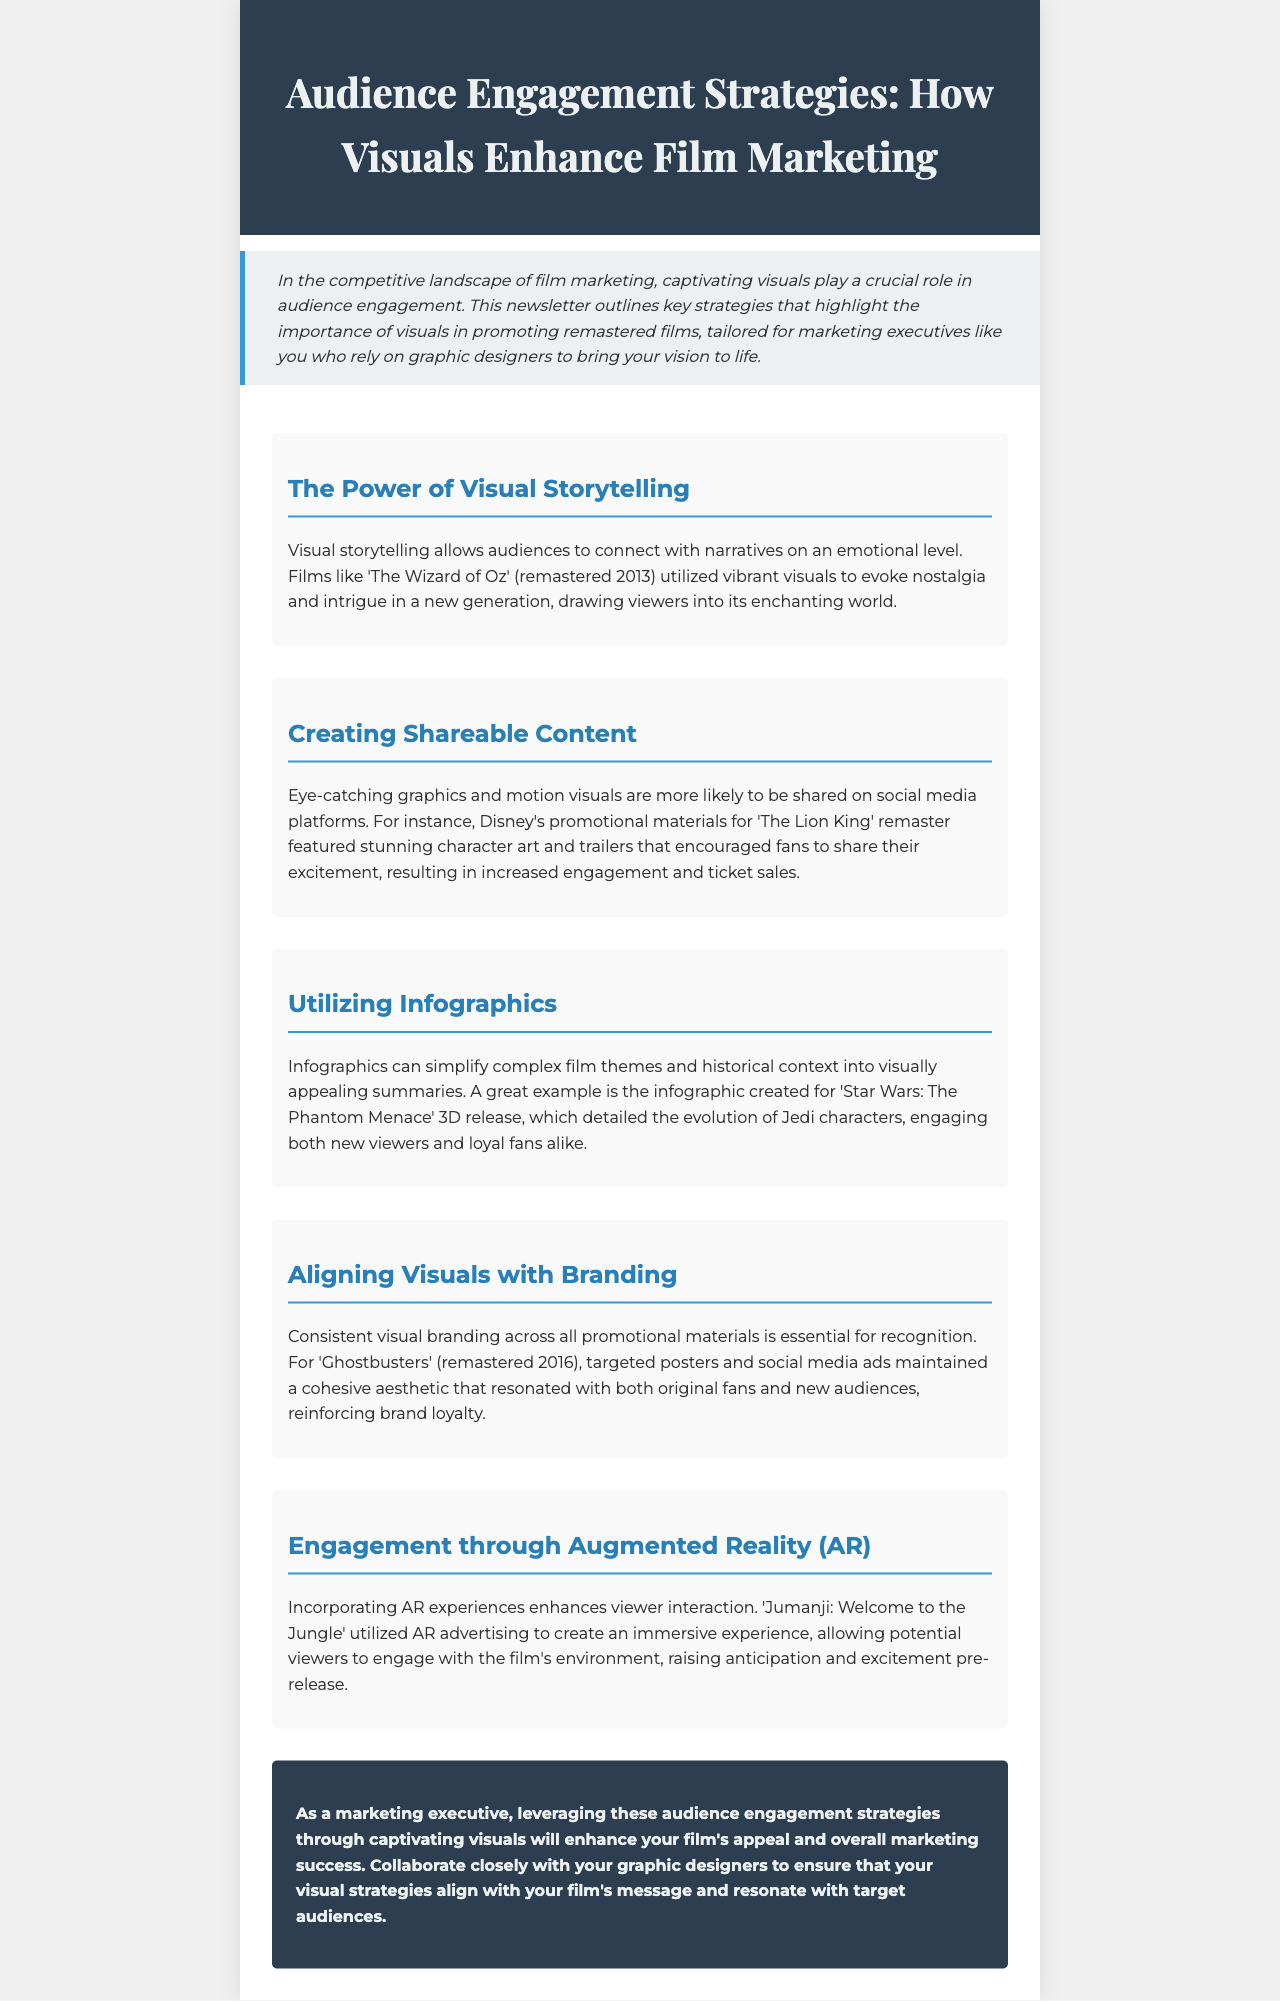What is the title of the newsletter? The title is stated in the header of the document, which is "Audience Engagement Strategies: How Visuals Enhance Film Marketing."
Answer: Audience Engagement Strategies: How Visuals Enhance Film Marketing What film was remastered in 2013? The document mentions 'The Wizard of Oz' as the remastered film in 2013.
Answer: The Wizard of Oz Which film utilized AR advertising? The document states 'Jumanji: Welcome to the Jungle' as the film that utilized AR advertising.
Answer: Jumanji: Welcome to the Jungle What marketing strategy encourages social media sharing? The document highlights that eye-catching graphics and motion visuals encourage social media sharing.
Answer: Eye-catching graphics and motion visuals Which film's promotional materials featured stunning character art? The document discusses Disney's promotional materials for 'The Lion King' remaster as featuring stunning character art.
Answer: The Lion King What engages both new viewers and loyal fans according to the newsletter? The infographic created for 'Star Wars: The Phantom Menace' 3D release engages both new viewers and loyal fans.
Answer: Infographic for 'Star Wars: The Phantom Menace' 3D release What year was 'Ghostbusters' remastered? The document states that 'Ghostbusters' was remastered in 2016.
Answer: 2016 What is a key element for recognition in film marketing visuals? The document mentions consistent visual branding as a key element for recognition in film marketing visuals.
Answer: Consistent visual branding 